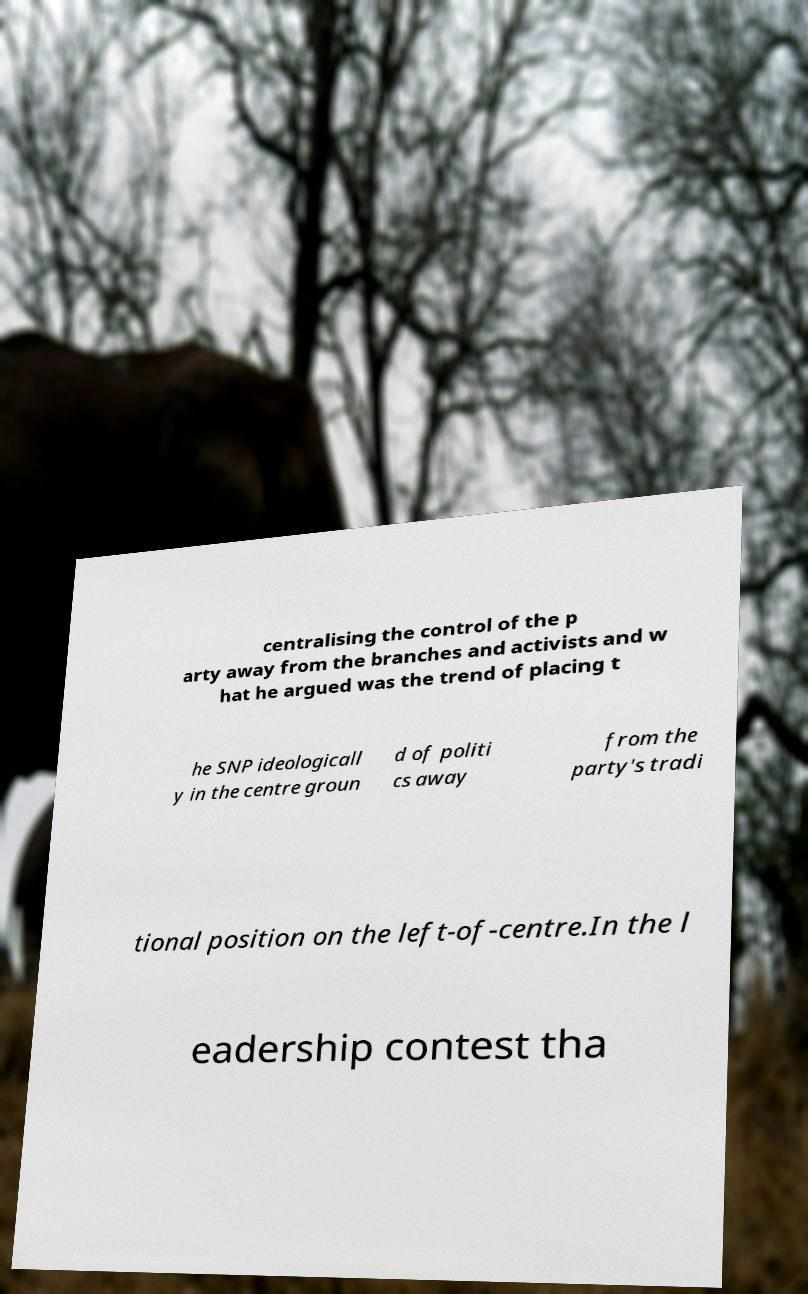For documentation purposes, I need the text within this image transcribed. Could you provide that? centralising the control of the p arty away from the branches and activists and w hat he argued was the trend of placing t he SNP ideologicall y in the centre groun d of politi cs away from the party's tradi tional position on the left-of-centre.In the l eadership contest tha 